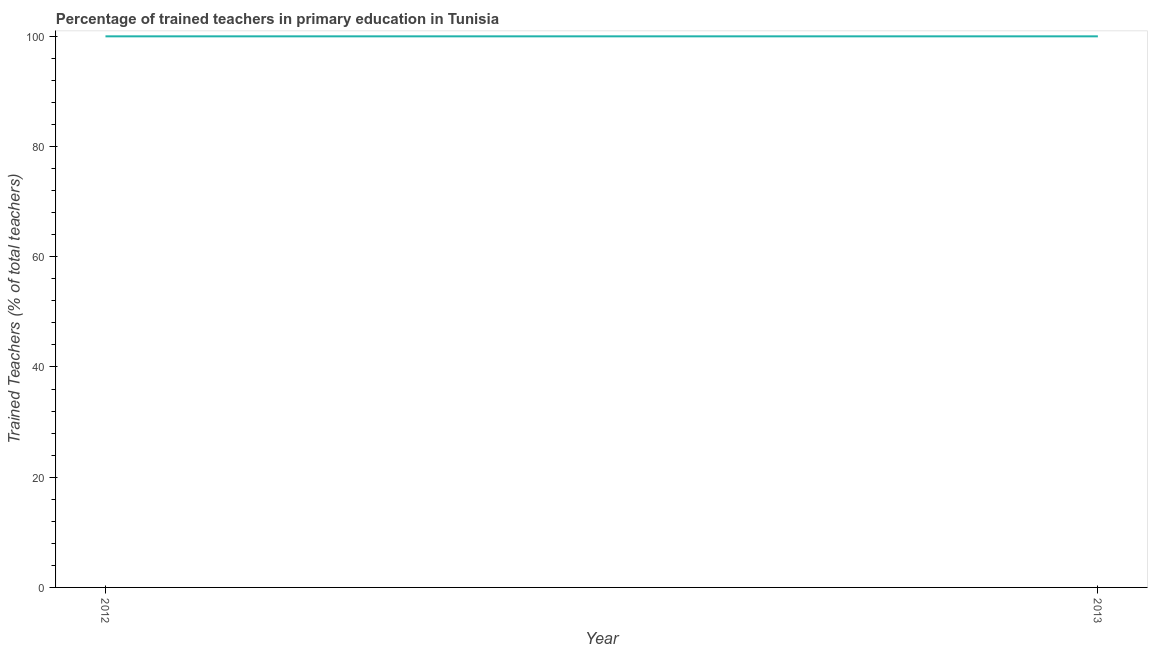What is the percentage of trained teachers in 2013?
Offer a terse response. 100. Across all years, what is the maximum percentage of trained teachers?
Provide a succinct answer. 100. Across all years, what is the minimum percentage of trained teachers?
Keep it short and to the point. 100. What is the sum of the percentage of trained teachers?
Provide a succinct answer. 200. What is the average percentage of trained teachers per year?
Keep it short and to the point. 100. Do a majority of the years between 2013 and 2012 (inclusive) have percentage of trained teachers greater than 32 %?
Make the answer very short. No. Is the percentage of trained teachers in 2012 less than that in 2013?
Offer a terse response. No. How many years are there in the graph?
Provide a succinct answer. 2. What is the difference between two consecutive major ticks on the Y-axis?
Keep it short and to the point. 20. Are the values on the major ticks of Y-axis written in scientific E-notation?
Provide a succinct answer. No. Does the graph contain grids?
Offer a terse response. No. What is the title of the graph?
Your response must be concise. Percentage of trained teachers in primary education in Tunisia. What is the label or title of the Y-axis?
Your answer should be compact. Trained Teachers (% of total teachers). What is the Trained Teachers (% of total teachers) in 2012?
Provide a succinct answer. 100. What is the Trained Teachers (% of total teachers) of 2013?
Give a very brief answer. 100. 